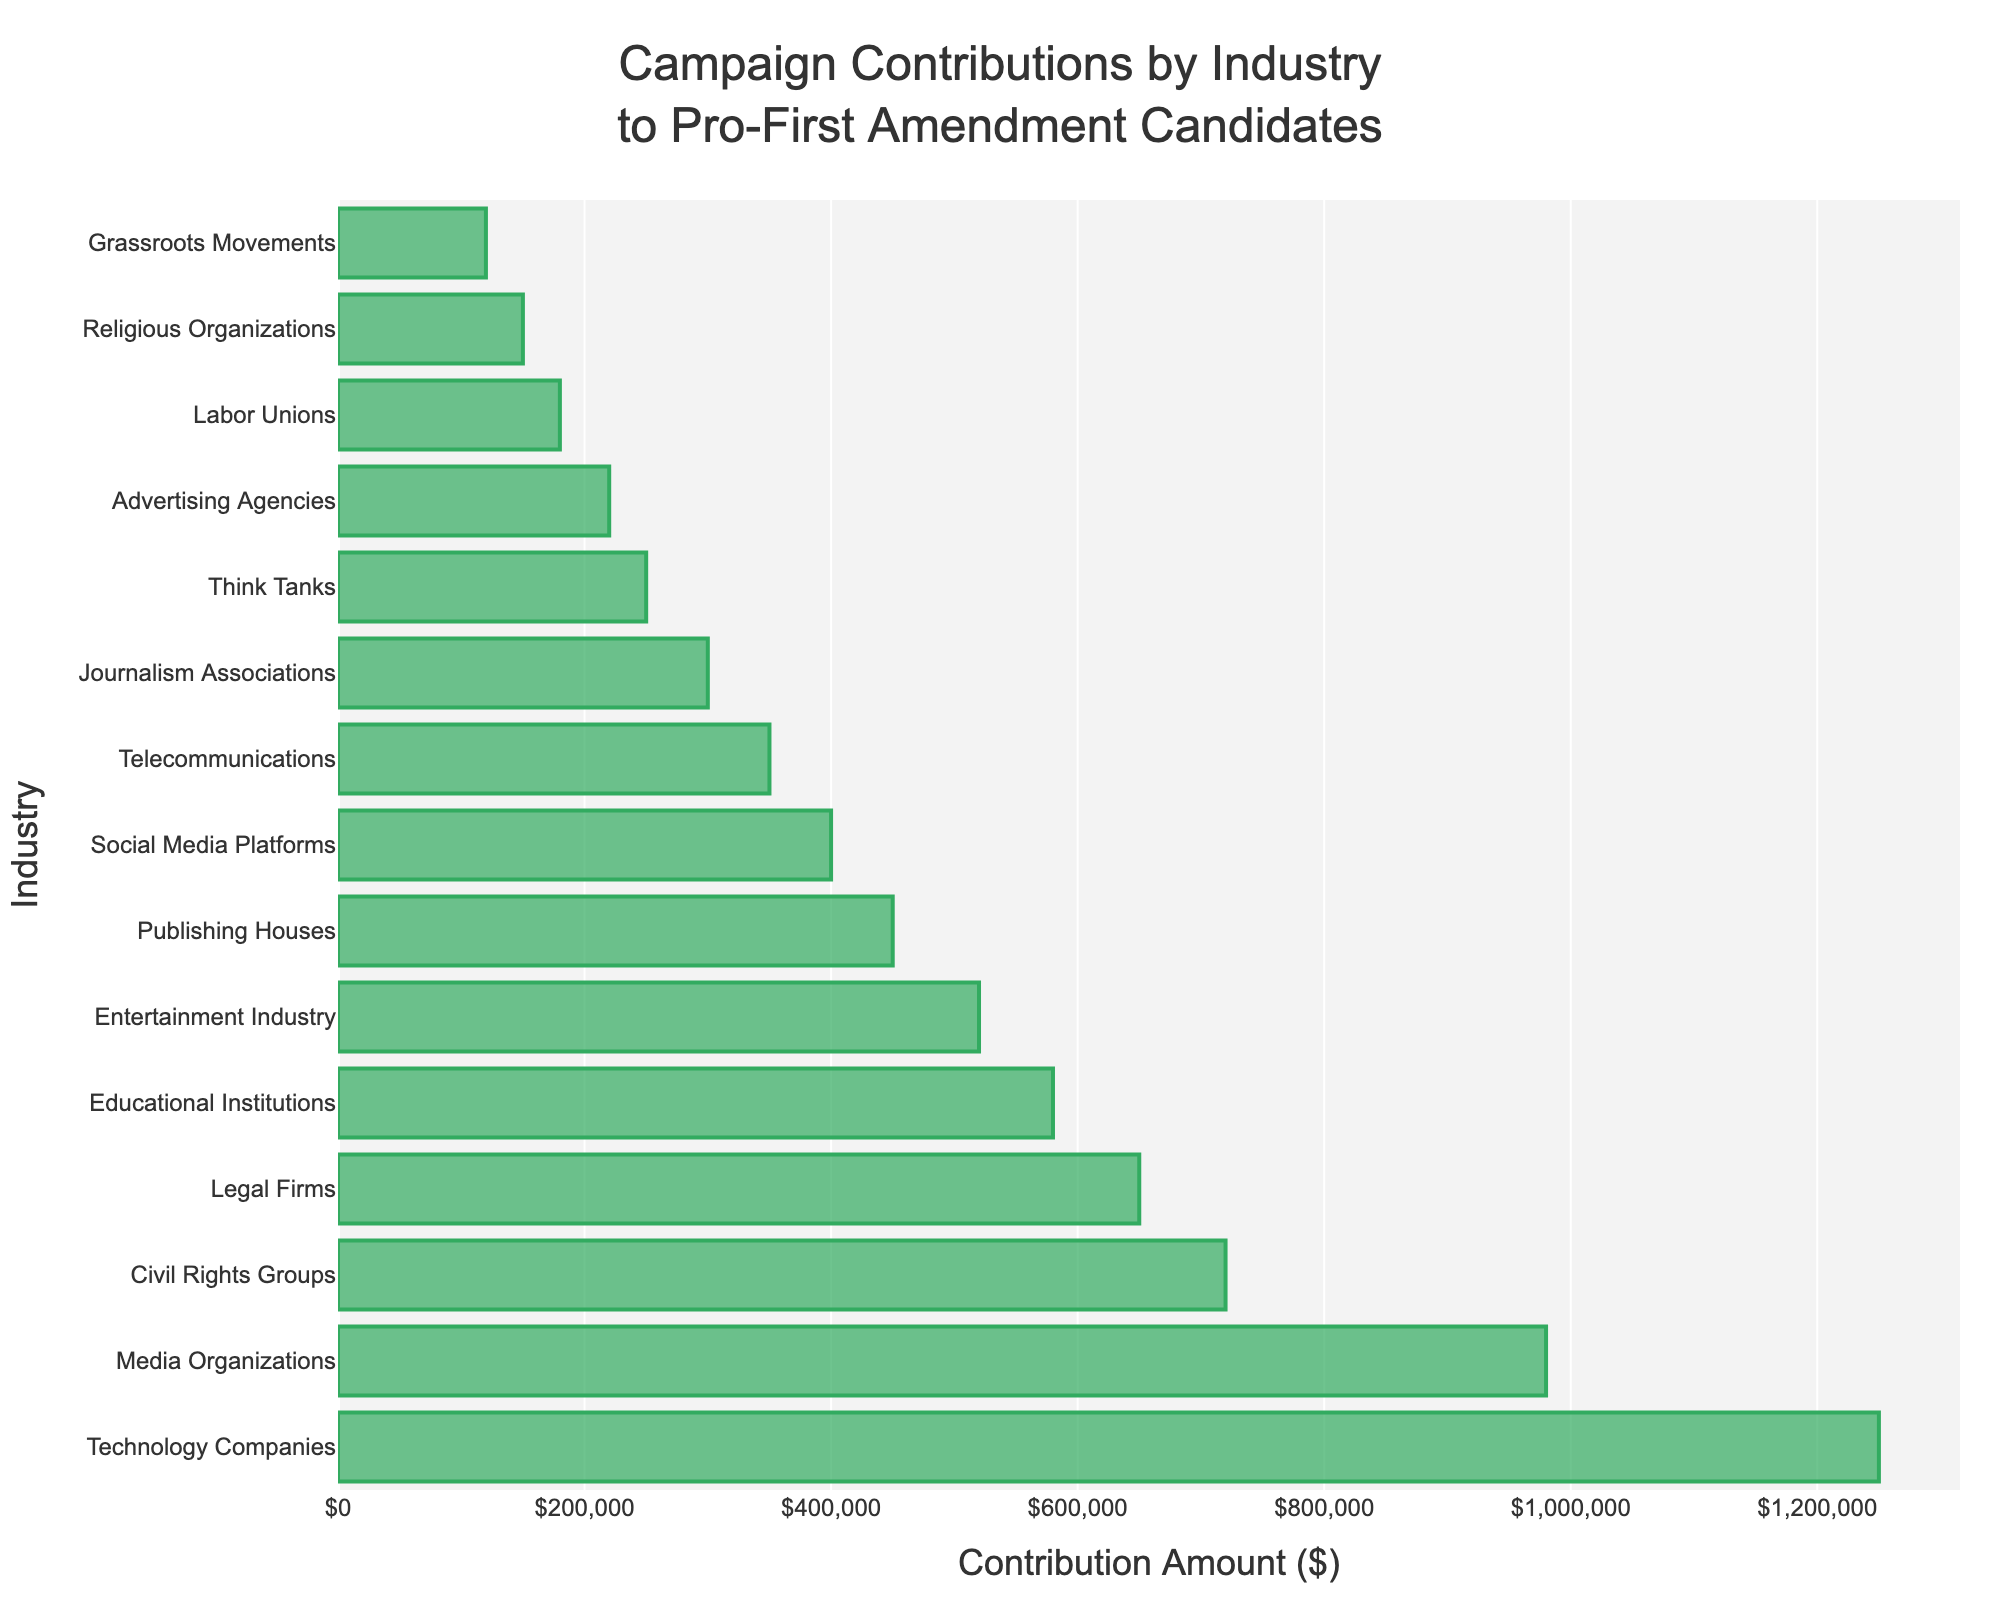What's the total campaign contribution from Technology Companies and Media Organizations? Add the contributions from Technology Companies ($1,250,000) and Media Organizations ($980,000): $1,250,000 + $980,000 = $2,230,000
Answer: $2,230,000 Which industry has the lowest campaign contribution? According to the bar chart, Grassroots Movements has the lowest campaign contribution of $120,000
Answer: Grassroots Movements How much more did Legal Firms contribute compared to Educational Institutions? Subtract the contribution of Educational Institutions ($580,000) from Legal Firms ($650,000): $650,000 - $580,000 = $70,000
Answer: $70,000 What's the average contribution amount from the top three contributing industries? The top three industries are Technology Companies ($1,250,000), Media Organizations ($980,000), and Civil Rights Groups ($720,000). The average is ($1,250,000 + $980,000 + $720,000) / 3 = $2,950,000 / 3 = $983,333.33
Answer: $983,333.33 Do Telecommunications contribute more than Think Tanks? Telecommunications contributed $350,000 while Think Tanks contributed $250,000. Comparing these values, Telecommunications contributed more
Answer: Yes What is the combined contribution from the bottom five industries? The bottom five are Labor Unions ($180,000), Religious Organizations ($150,000), Grassroots Movements ($120,000), Environmental Groups ($110,000), Env. Non-profits ($100,000). Their combined contribution is $180,000 + $150,000 + $120,000 + $110,000 + $100,000 = $660,000
Answer: $660,000 What is the median campaign contribution amount? There are 16 industries. To find the median, sort the contributions and take the average of the 8th and 9th values. Sorted contributions: $1,250,000, $980,000, $720,000, $650,000, $580,000, $520,000, $450,000, $400,000 (8th), $350,000 (9th), $300,000, $250,000, $220,000, $180,000, $150,000, $120,000. The median is ($400,000 + $350,000) / 2 = $375,000
Answer: $375,000 Which industry contributed the second most? According to the bar chart, Media Organizations contributed the second most with $980,000
Answer: Media Organizations How does the contribution from Social Media Platforms compare with that from Journalism Associations? Social Media Platforms contributed $400,000, and Journalism Associations contributed $300,000. Social Media Platforms contributed more
Answer: Social Media Platforms 